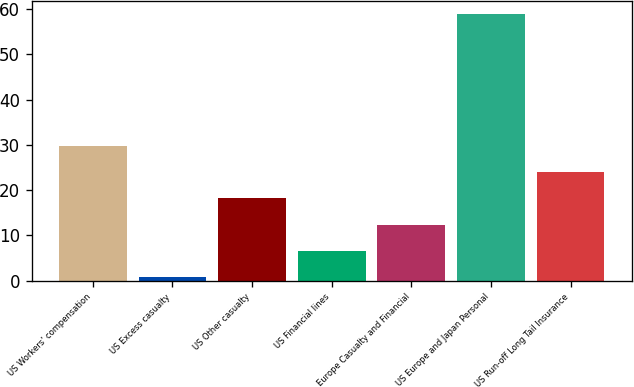Convert chart. <chart><loc_0><loc_0><loc_500><loc_500><bar_chart><fcel>US Workers' compensation<fcel>US Excess casualty<fcel>US Other casualty<fcel>US Financial lines<fcel>Europe Casualty and Financial<fcel>US Europe and Japan Personal<fcel>US Run-off Long Tail Insurance<nl><fcel>29.8<fcel>0.7<fcel>18.16<fcel>6.52<fcel>12.34<fcel>58.9<fcel>23.98<nl></chart> 